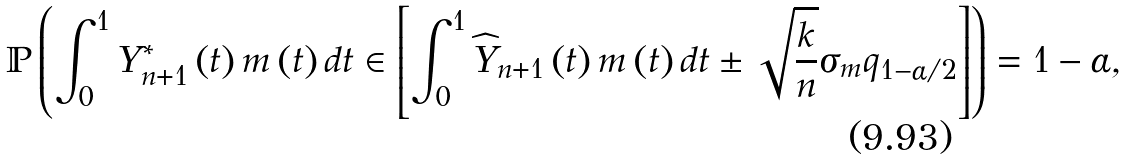Convert formula to latex. <formula><loc_0><loc_0><loc_500><loc_500>\mathbb { P } \left ( \int _ { 0 } ^ { 1 } Y _ { n + 1 } ^ { \ast } \left ( t \right ) m \left ( t \right ) d t \in \left [ \int _ { 0 } ^ { 1 } \widehat { Y } _ { n + 1 } \left ( t \right ) m \left ( t \right ) d t \pm \sqrt { \frac { k } { n } } \sigma _ { m } q _ { 1 - \alpha / 2 } \right ] \right ) = 1 - \alpha ,</formula> 